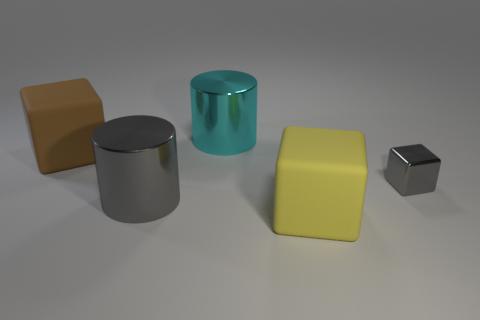Subtract all matte blocks. How many blocks are left? 1 Subtract all cyan cylinders. How many cylinders are left? 1 Add 3 matte things. How many objects exist? 8 Subtract all cylinders. How many objects are left? 3 Subtract all small metal cylinders. Subtract all small gray blocks. How many objects are left? 4 Add 2 gray objects. How many gray objects are left? 4 Add 4 cylinders. How many cylinders exist? 6 Subtract 0 purple blocks. How many objects are left? 5 Subtract 2 cubes. How many cubes are left? 1 Subtract all gray cylinders. Subtract all purple spheres. How many cylinders are left? 1 